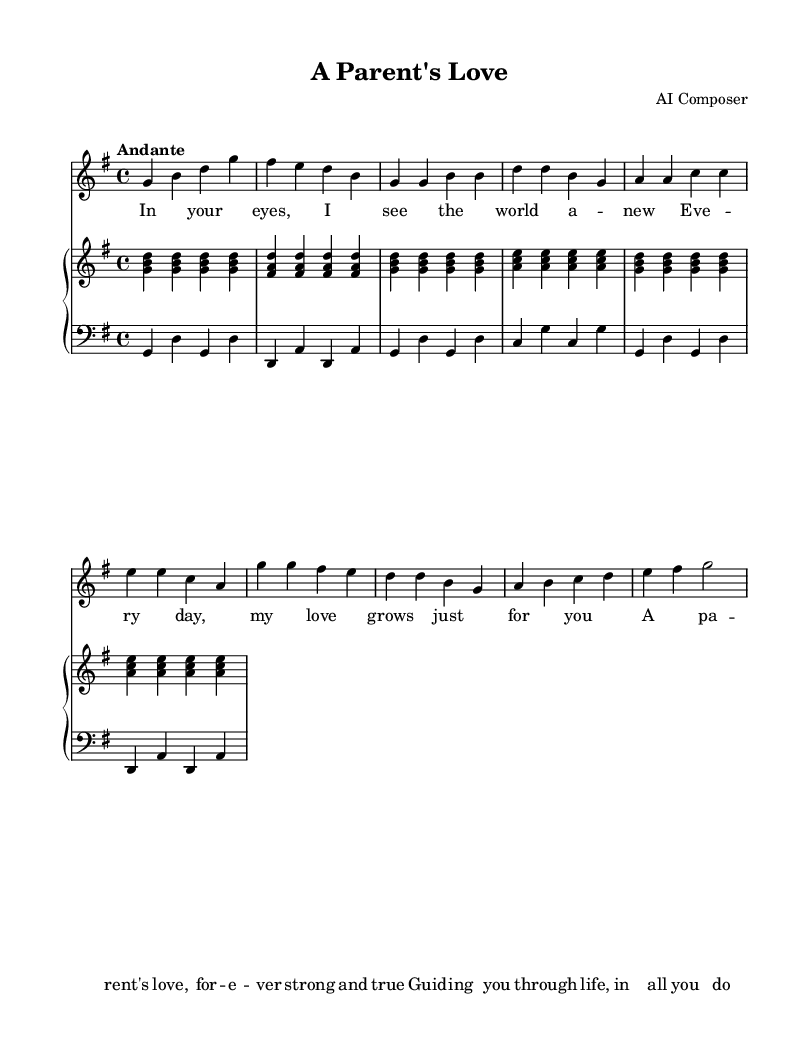What is the key signature of this music? The key signature is G major, indicated by one sharp (F#).
Answer: G major What is the time signature of this piece? The time signature is 4/4, meaning there are four beats in a measure.
Answer: 4/4 What is the tempo marking of the piece? The tempo marking is "Andante," which suggests a moderately slow tempo.
Answer: Andante What is the highest note in the soprano part? The highest note in the soprano part is g', which is indicated by the note on the second line from the top of the staff.
Answer: g' What is the structure of this opera piece? The piece consists of an introduction, a verse, and a chorus, as indicated by the layout of the music and lyrics.
Answer: Introduction, Verse, Chorus How many measures are in the chorus section? The chorus section has a total of 8 measures, as counted from the notation provided.
Answer: 8 measures What emotion does the lyrics of this opera try to convey? The lyrics express love and guidance, emphasizing the strength of a parent's love.
Answer: Love and guidance 